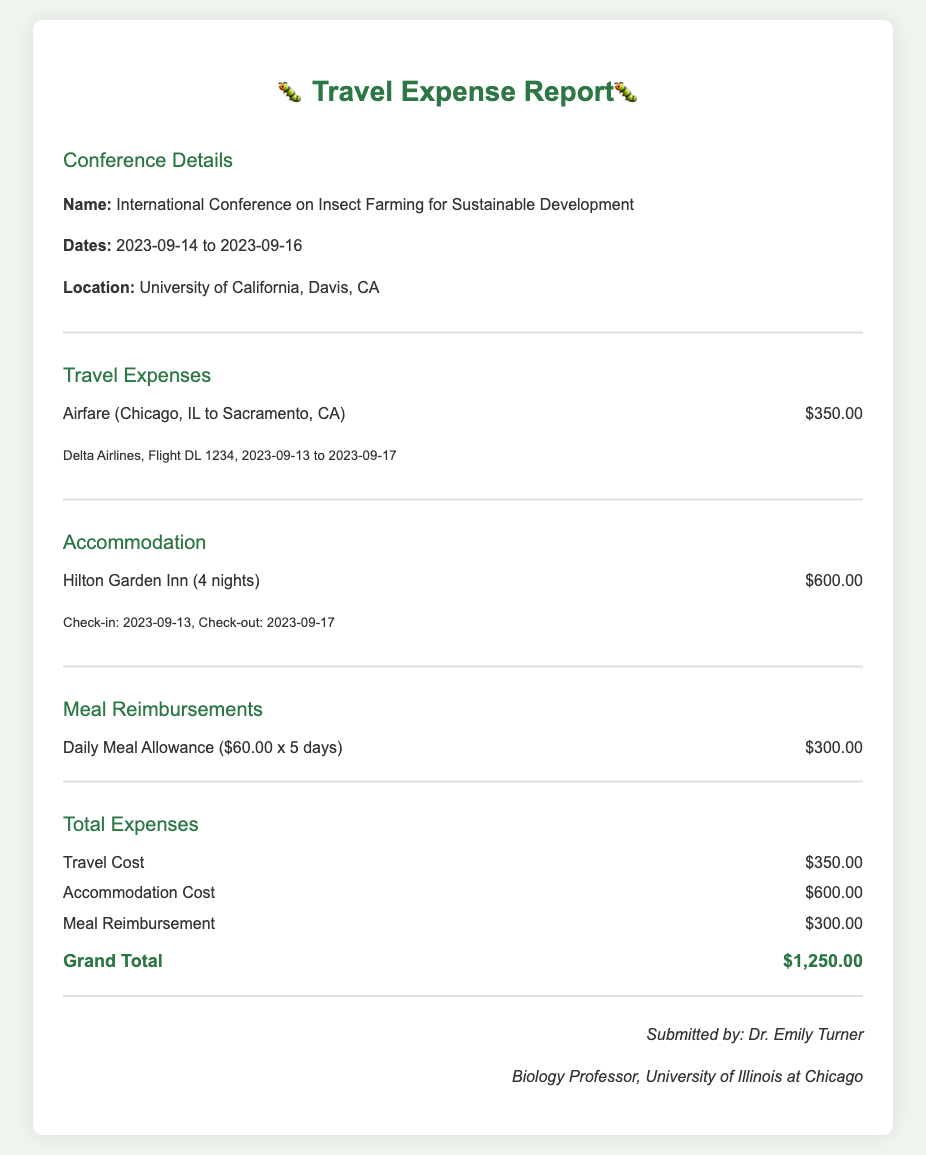What was the total airfare for the trip? The airfare for the trip listed in the document is $350.00.
Answer: $350.00 What hotel was used for accommodation? The accommodation section mentions Hilton Garden Inn.
Answer: Hilton Garden Inn How many nights did the accommodation last? The document indicates that the accommodation lasted for 4 nights.
Answer: 4 nights What is the total amount for meal reimbursements? The total for meal reimbursements listed is $300.00.
Answer: $300.00 What is the grand total of all expenses? The grand total is the sum of airfare, accommodation, and meal reimbursements, which equals $1,250.00.
Answer: $1,250.00 When did the conference take place? The conference dates listed are from September 14 to September 16, 2023.
Answer: September 14 to September 16, 2023 Who submitted the expense report? The report states it was submitted by Dr. Emily Turner.
Answer: Dr. Emily Turner What city was the conference located in? The conference took place in Davis, CA.
Answer: Davis, CA How many days was the meal allowance calculated? The meal allowance calculation was for 5 days.
Answer: 5 days 